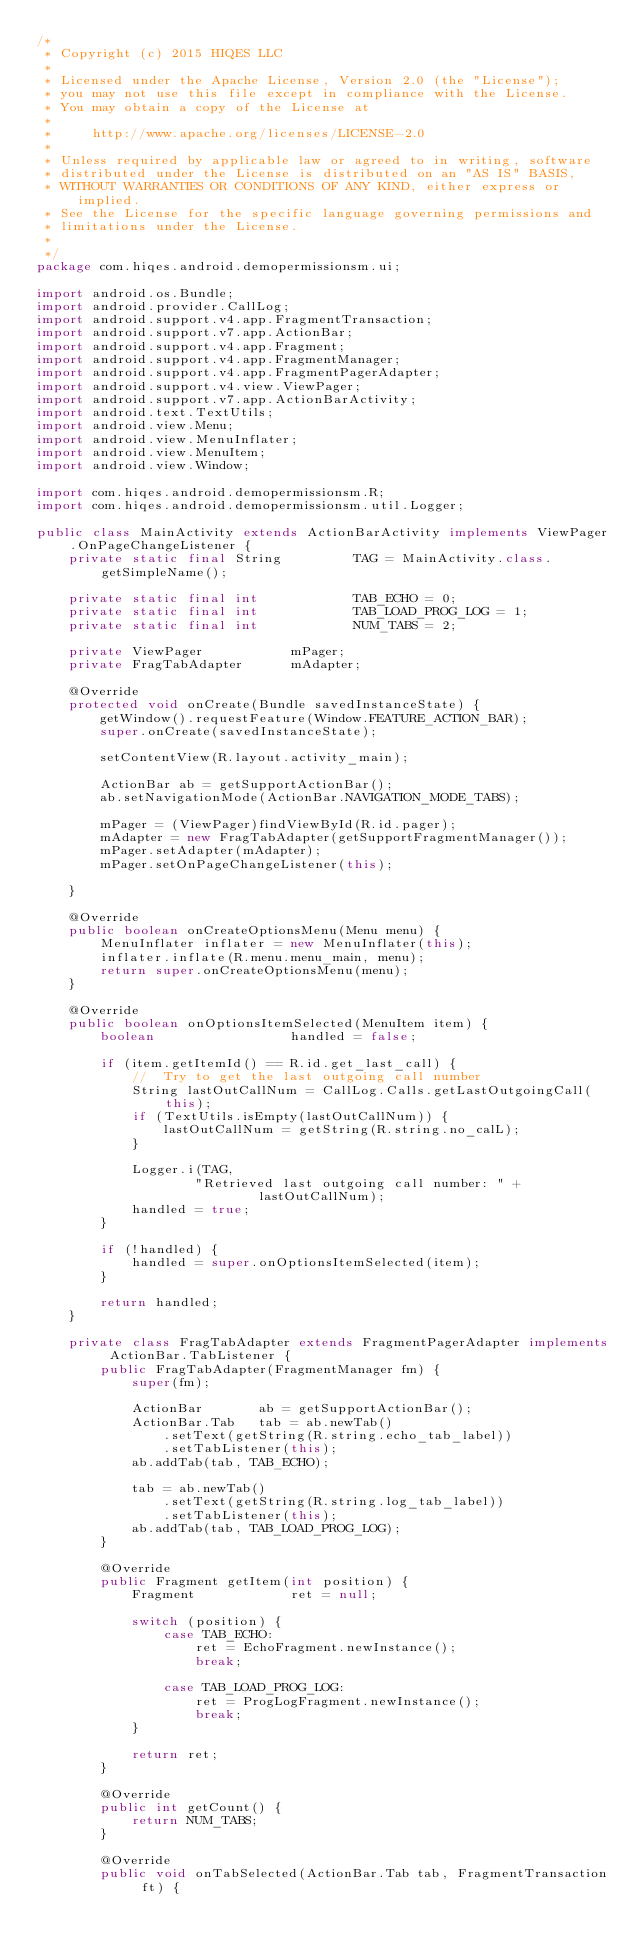<code> <loc_0><loc_0><loc_500><loc_500><_Java_>/*
 * Copyright (c) 2015 HIQES LLC
 *
 * Licensed under the Apache License, Version 2.0 (the "License");
 * you may not use this file except in compliance with the License.
 * You may obtain a copy of the License at
 *
 *     http://www.apache.org/licenses/LICENSE-2.0
 *
 * Unless required by applicable law or agreed to in writing, software
 * distributed under the License is distributed on an "AS IS" BASIS,
 * WITHOUT WARRANTIES OR CONDITIONS OF ANY KIND, either express or implied.
 * See the License for the specific language governing permissions and
 * limitations under the License.
 *
 */
package com.hiqes.android.demopermissionsm.ui;

import android.os.Bundle;
import android.provider.CallLog;
import android.support.v4.app.FragmentTransaction;
import android.support.v7.app.ActionBar;
import android.support.v4.app.Fragment;
import android.support.v4.app.FragmentManager;
import android.support.v4.app.FragmentPagerAdapter;
import android.support.v4.view.ViewPager;
import android.support.v7.app.ActionBarActivity;
import android.text.TextUtils;
import android.view.Menu;
import android.view.MenuInflater;
import android.view.MenuItem;
import android.view.Window;

import com.hiqes.android.demopermissionsm.R;
import com.hiqes.android.demopermissionsm.util.Logger;

public class MainActivity extends ActionBarActivity implements ViewPager.OnPageChangeListener {
    private static final String         TAG = MainActivity.class.getSimpleName();

    private static final int            TAB_ECHO = 0;
    private static final int            TAB_LOAD_PROG_LOG = 1;
    private static final int            NUM_TABS = 2;

    private ViewPager           mPager;
    private FragTabAdapter      mAdapter;

    @Override
    protected void onCreate(Bundle savedInstanceState) {
        getWindow().requestFeature(Window.FEATURE_ACTION_BAR);
        super.onCreate(savedInstanceState);

        setContentView(R.layout.activity_main);

        ActionBar ab = getSupportActionBar();
        ab.setNavigationMode(ActionBar.NAVIGATION_MODE_TABS);

        mPager = (ViewPager)findViewById(R.id.pager);
        mAdapter = new FragTabAdapter(getSupportFragmentManager());
        mPager.setAdapter(mAdapter);
        mPager.setOnPageChangeListener(this);

    }

    @Override
    public boolean onCreateOptionsMenu(Menu menu) {
        MenuInflater inflater = new MenuInflater(this);
        inflater.inflate(R.menu.menu_main, menu);
        return super.onCreateOptionsMenu(menu);
    }

    @Override
    public boolean onOptionsItemSelected(MenuItem item) {
        boolean                 handled = false;

        if (item.getItemId() == R.id.get_last_call) {
            //  Try to get the last outgoing call number
            String lastOutCallNum = CallLog.Calls.getLastOutgoingCall(this);
            if (TextUtils.isEmpty(lastOutCallNum)) {
                lastOutCallNum = getString(R.string.no_calL);
            }

            Logger.i(TAG,
                    "Retrieved last outgoing call number: " +
                            lastOutCallNum);
            handled = true;
        }

        if (!handled) {
            handled = super.onOptionsItemSelected(item);
        }

        return handled;
    }

    private class FragTabAdapter extends FragmentPagerAdapter implements ActionBar.TabListener {
        public FragTabAdapter(FragmentManager fm) {
            super(fm);

            ActionBar       ab = getSupportActionBar();
            ActionBar.Tab   tab = ab.newTab()
                .setText(getString(R.string.echo_tab_label))
                .setTabListener(this);
            ab.addTab(tab, TAB_ECHO);

            tab = ab.newTab()
                .setText(getString(R.string.log_tab_label))
                .setTabListener(this);
            ab.addTab(tab, TAB_LOAD_PROG_LOG);
        }

        @Override
        public Fragment getItem(int position) {
            Fragment            ret = null;

            switch (position) {
                case TAB_ECHO:
                    ret = EchoFragment.newInstance();
                    break;

                case TAB_LOAD_PROG_LOG:
                    ret = ProgLogFragment.newInstance();
                    break;
            }

            return ret;
        }

        @Override
        public int getCount() {
            return NUM_TABS;
        }

        @Override
        public void onTabSelected(ActionBar.Tab tab, FragmentTransaction ft) {</code> 